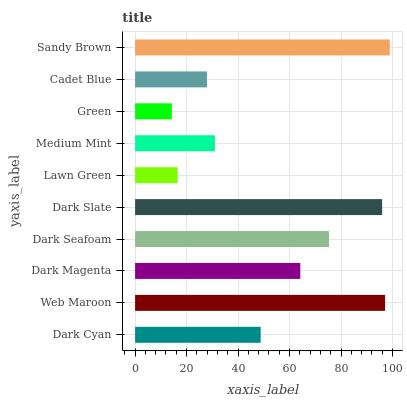Is Green the minimum?
Answer yes or no. Yes. Is Sandy Brown the maximum?
Answer yes or no. Yes. Is Web Maroon the minimum?
Answer yes or no. No. Is Web Maroon the maximum?
Answer yes or no. No. Is Web Maroon greater than Dark Cyan?
Answer yes or no. Yes. Is Dark Cyan less than Web Maroon?
Answer yes or no. Yes. Is Dark Cyan greater than Web Maroon?
Answer yes or no. No. Is Web Maroon less than Dark Cyan?
Answer yes or no. No. Is Dark Magenta the high median?
Answer yes or no. Yes. Is Dark Cyan the low median?
Answer yes or no. Yes. Is Cadet Blue the high median?
Answer yes or no. No. Is Web Maroon the low median?
Answer yes or no. No. 